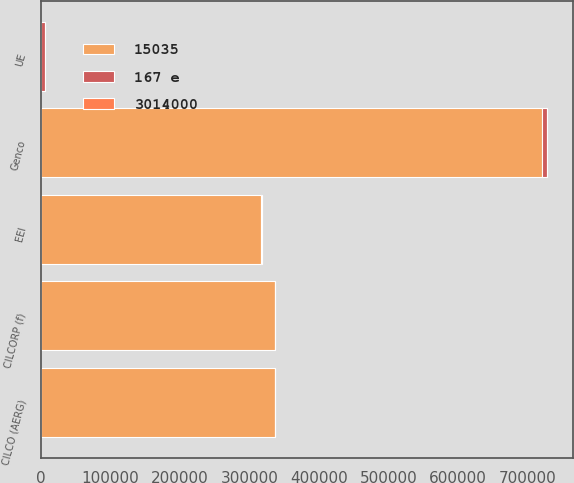Convert chart. <chart><loc_0><loc_0><loc_500><loc_500><stacked_bar_chart><ecel><fcel>UE<fcel>Genco<fcel>CILCORP (f)<fcel>CILCO (AERG)<fcel>EEI<nl><fcel>15035<fcel>702.5<fcel>720000<fcel>337000<fcel>337000<fcel>317000<nl><fcel>167 e<fcel>5505<fcel>8125<fcel>209<fcel>209<fcel>1196<nl><fcel>3014000<fcel>48<fcel>49<fcel>35<fcel>1<fcel>9<nl></chart> 